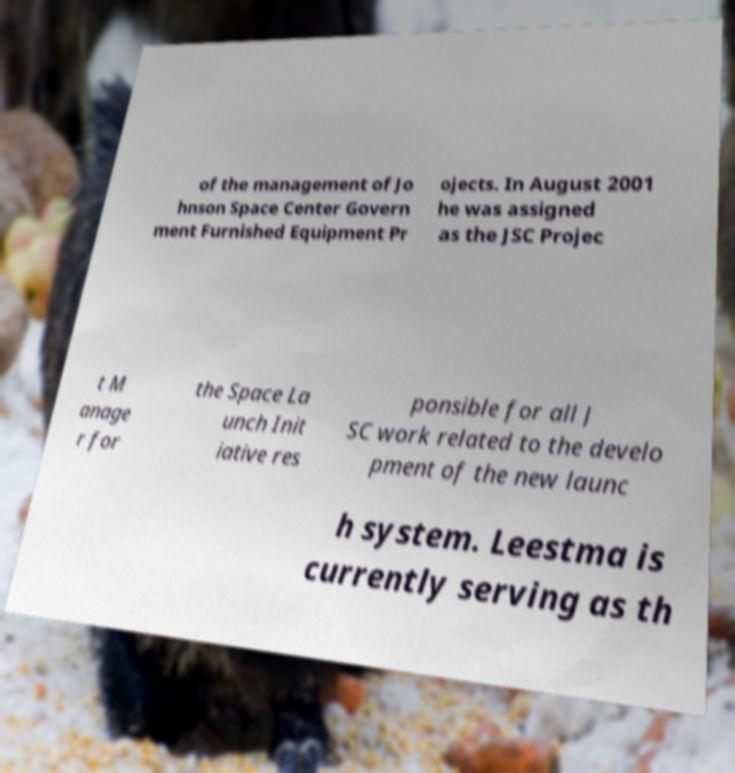Could you assist in decoding the text presented in this image and type it out clearly? of the management of Jo hnson Space Center Govern ment Furnished Equipment Pr ojects. In August 2001 he was assigned as the JSC Projec t M anage r for the Space La unch Init iative res ponsible for all J SC work related to the develo pment of the new launc h system. Leestma is currently serving as th 